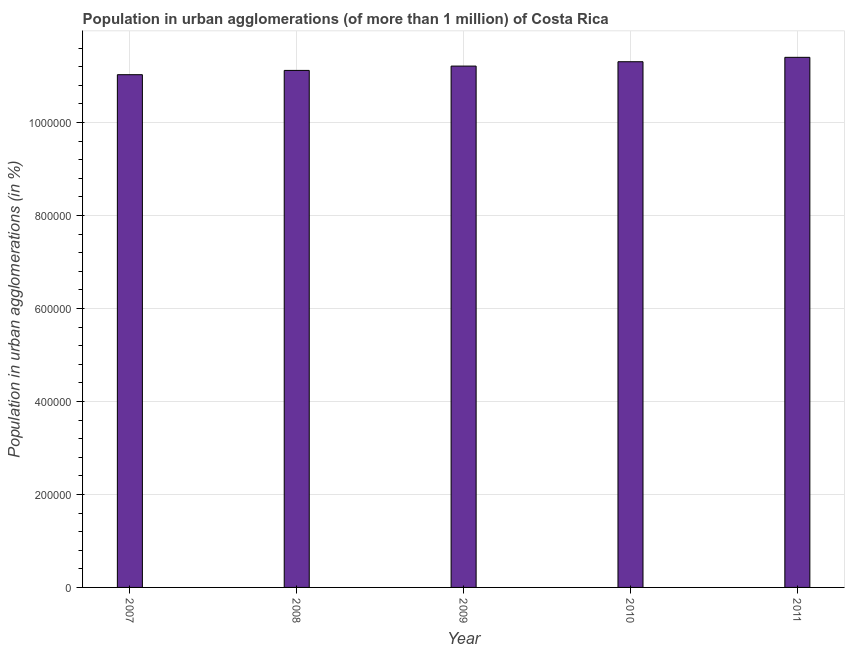Does the graph contain any zero values?
Offer a terse response. No. Does the graph contain grids?
Make the answer very short. Yes. What is the title of the graph?
Give a very brief answer. Population in urban agglomerations (of more than 1 million) of Costa Rica. What is the label or title of the Y-axis?
Offer a very short reply. Population in urban agglomerations (in %). What is the population in urban agglomerations in 2010?
Provide a succinct answer. 1.13e+06. Across all years, what is the maximum population in urban agglomerations?
Your answer should be compact. 1.14e+06. Across all years, what is the minimum population in urban agglomerations?
Offer a very short reply. 1.10e+06. In which year was the population in urban agglomerations maximum?
Offer a very short reply. 2011. In which year was the population in urban agglomerations minimum?
Give a very brief answer. 2007. What is the sum of the population in urban agglomerations?
Offer a terse response. 5.61e+06. What is the difference between the population in urban agglomerations in 2007 and 2009?
Your response must be concise. -1.85e+04. What is the average population in urban agglomerations per year?
Your answer should be compact. 1.12e+06. What is the median population in urban agglomerations?
Make the answer very short. 1.12e+06. In how many years, is the population in urban agglomerations greater than 640000 %?
Your answer should be very brief. 5. Do a majority of the years between 2008 and 2011 (inclusive) have population in urban agglomerations greater than 360000 %?
Offer a terse response. Yes. Is the difference between the population in urban agglomerations in 2008 and 2011 greater than the difference between any two years?
Ensure brevity in your answer.  No. What is the difference between the highest and the second highest population in urban agglomerations?
Make the answer very short. 9455. What is the difference between the highest and the lowest population in urban agglomerations?
Make the answer very short. 3.73e+04. What is the difference between two consecutive major ticks on the Y-axis?
Ensure brevity in your answer.  2.00e+05. What is the Population in urban agglomerations (in %) in 2007?
Your response must be concise. 1.10e+06. What is the Population in urban agglomerations (in %) of 2008?
Keep it short and to the point. 1.11e+06. What is the Population in urban agglomerations (in %) in 2009?
Keep it short and to the point. 1.12e+06. What is the Population in urban agglomerations (in %) in 2010?
Your answer should be very brief. 1.13e+06. What is the Population in urban agglomerations (in %) of 2011?
Offer a very short reply. 1.14e+06. What is the difference between the Population in urban agglomerations (in %) in 2007 and 2008?
Provide a short and direct response. -9210. What is the difference between the Population in urban agglomerations (in %) in 2007 and 2009?
Your response must be concise. -1.85e+04. What is the difference between the Population in urban agglomerations (in %) in 2007 and 2010?
Ensure brevity in your answer.  -2.79e+04. What is the difference between the Population in urban agglomerations (in %) in 2007 and 2011?
Keep it short and to the point. -3.73e+04. What is the difference between the Population in urban agglomerations (in %) in 2008 and 2009?
Offer a terse response. -9300. What is the difference between the Population in urban agglomerations (in %) in 2008 and 2010?
Offer a terse response. -1.87e+04. What is the difference between the Population in urban agglomerations (in %) in 2008 and 2011?
Offer a terse response. -2.81e+04. What is the difference between the Population in urban agglomerations (in %) in 2009 and 2010?
Offer a terse response. -9377. What is the difference between the Population in urban agglomerations (in %) in 2009 and 2011?
Ensure brevity in your answer.  -1.88e+04. What is the difference between the Population in urban agglomerations (in %) in 2010 and 2011?
Make the answer very short. -9455. What is the ratio of the Population in urban agglomerations (in %) in 2007 to that in 2008?
Make the answer very short. 0.99. What is the ratio of the Population in urban agglomerations (in %) in 2009 to that in 2010?
Provide a short and direct response. 0.99. 